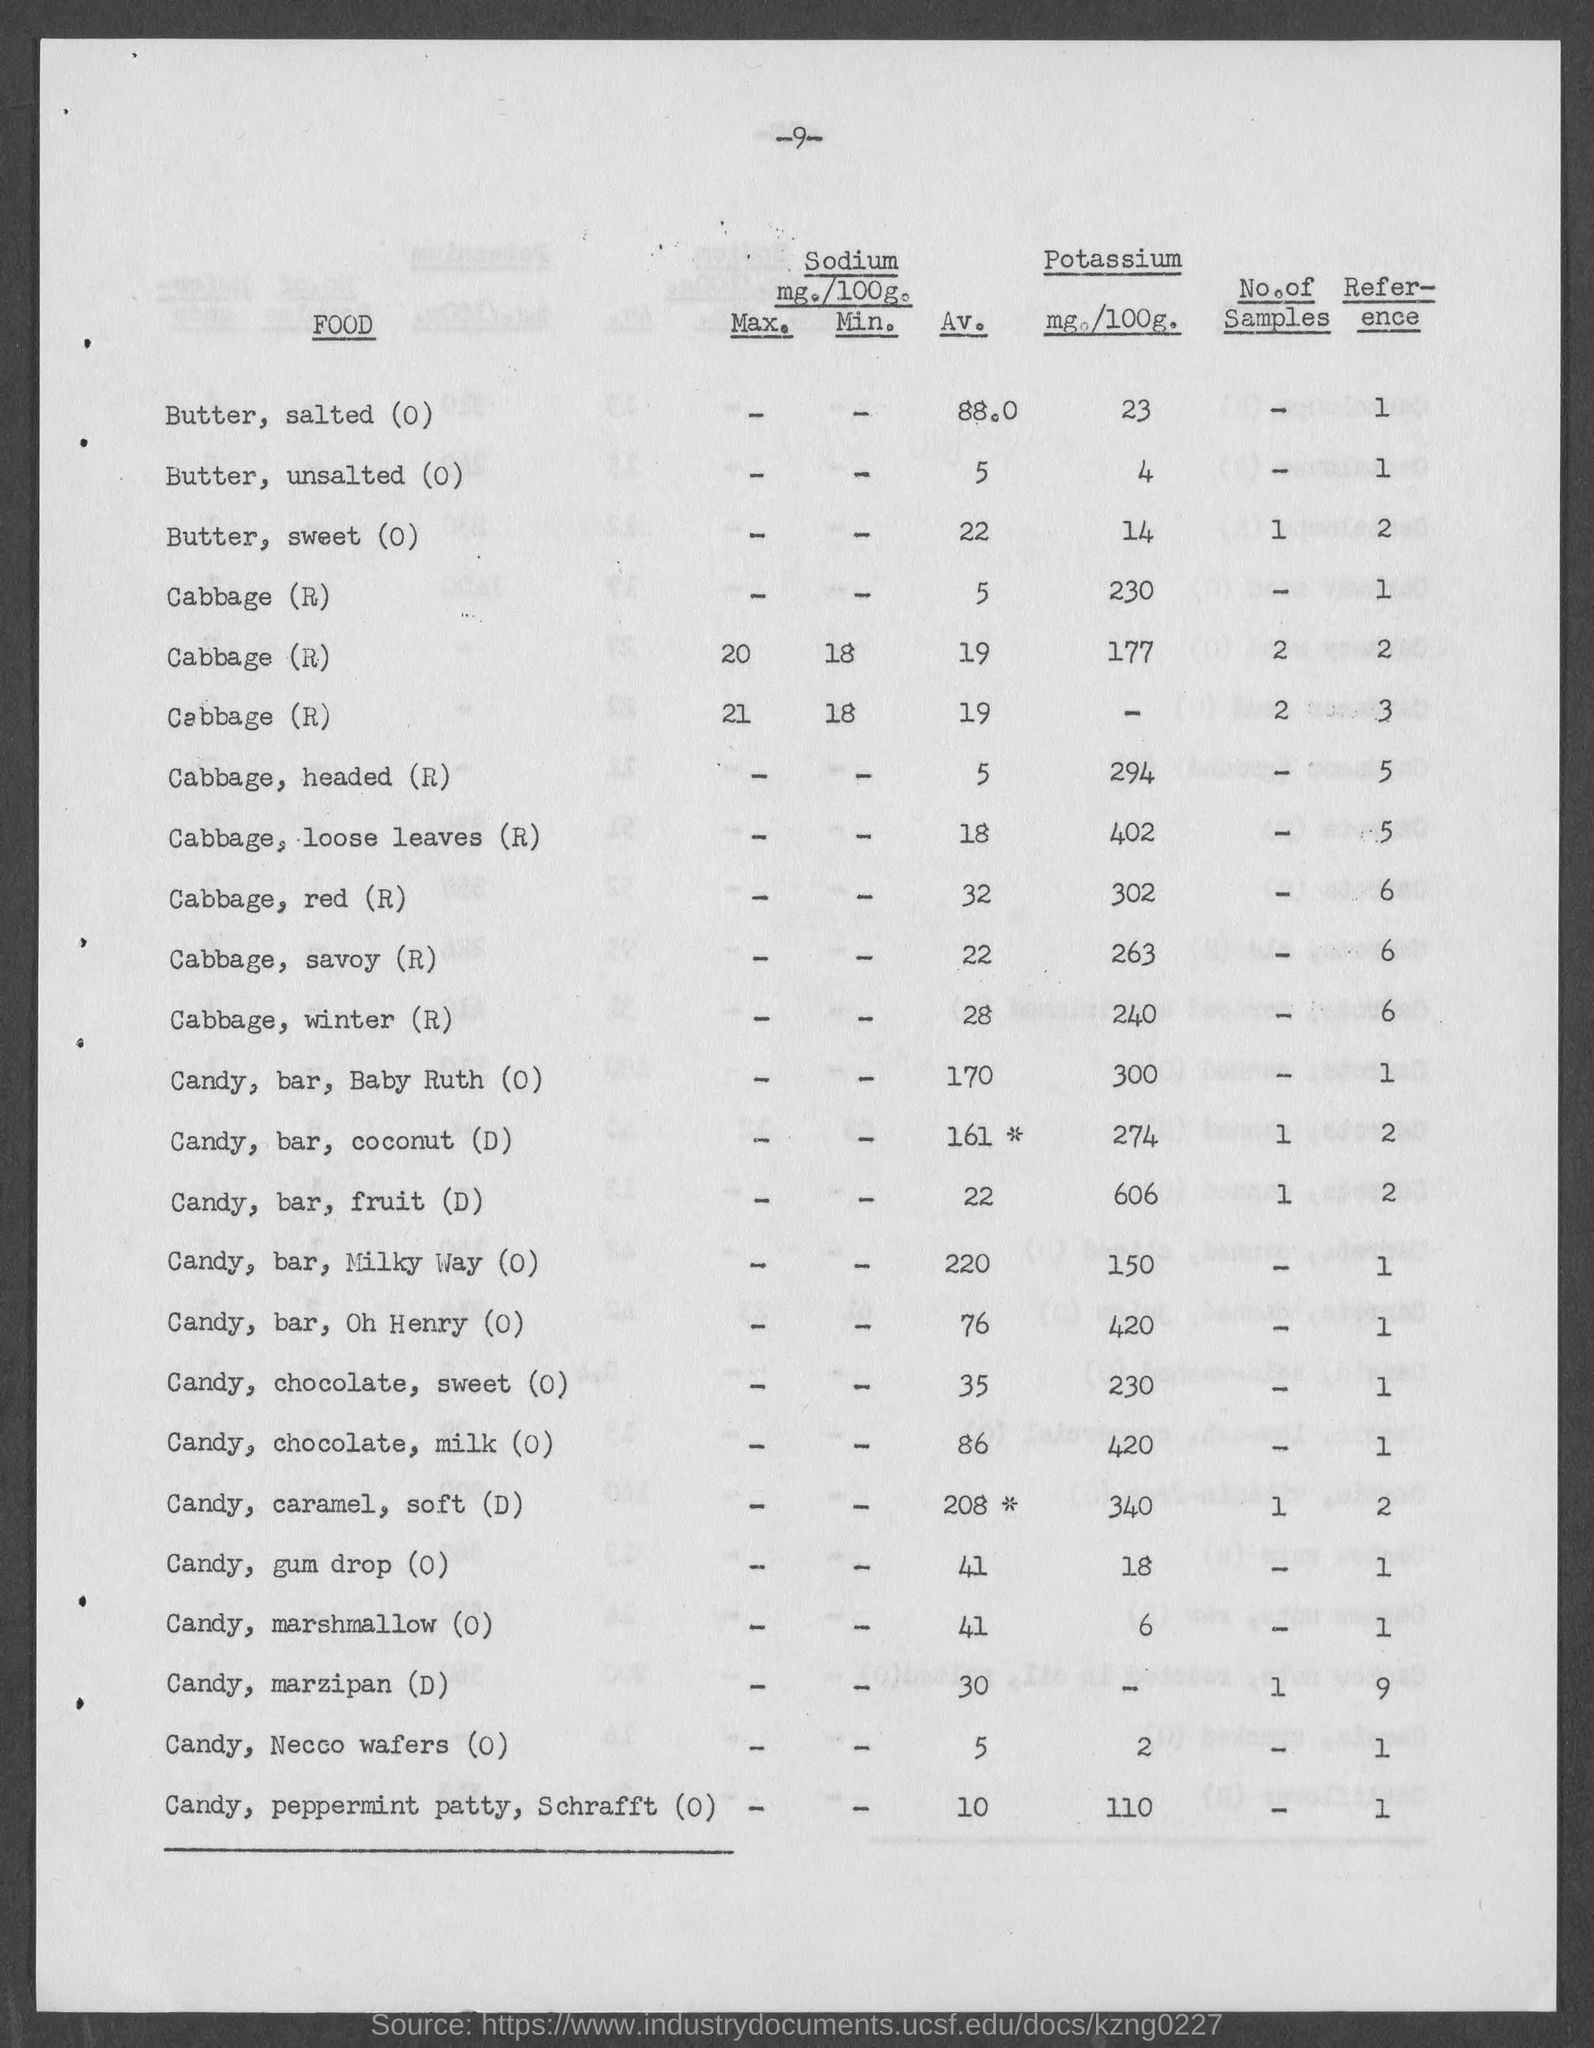Specify some key components in this picture. The amount of potassium present in candy, specifically gum drops, is mentioned on the given page. The amount of potassium present in cabbage, specifically red cabbage as per the given page, is 302. The amount of potassium present in butter, as mentioned in the given page, is 14.. The amount of potassium present in candy, bar, and fruit (D) is mentioned on the given page. The amount of potassium present in cabbage, specifically winter cabbage as mentioned on the given page, is 240. 